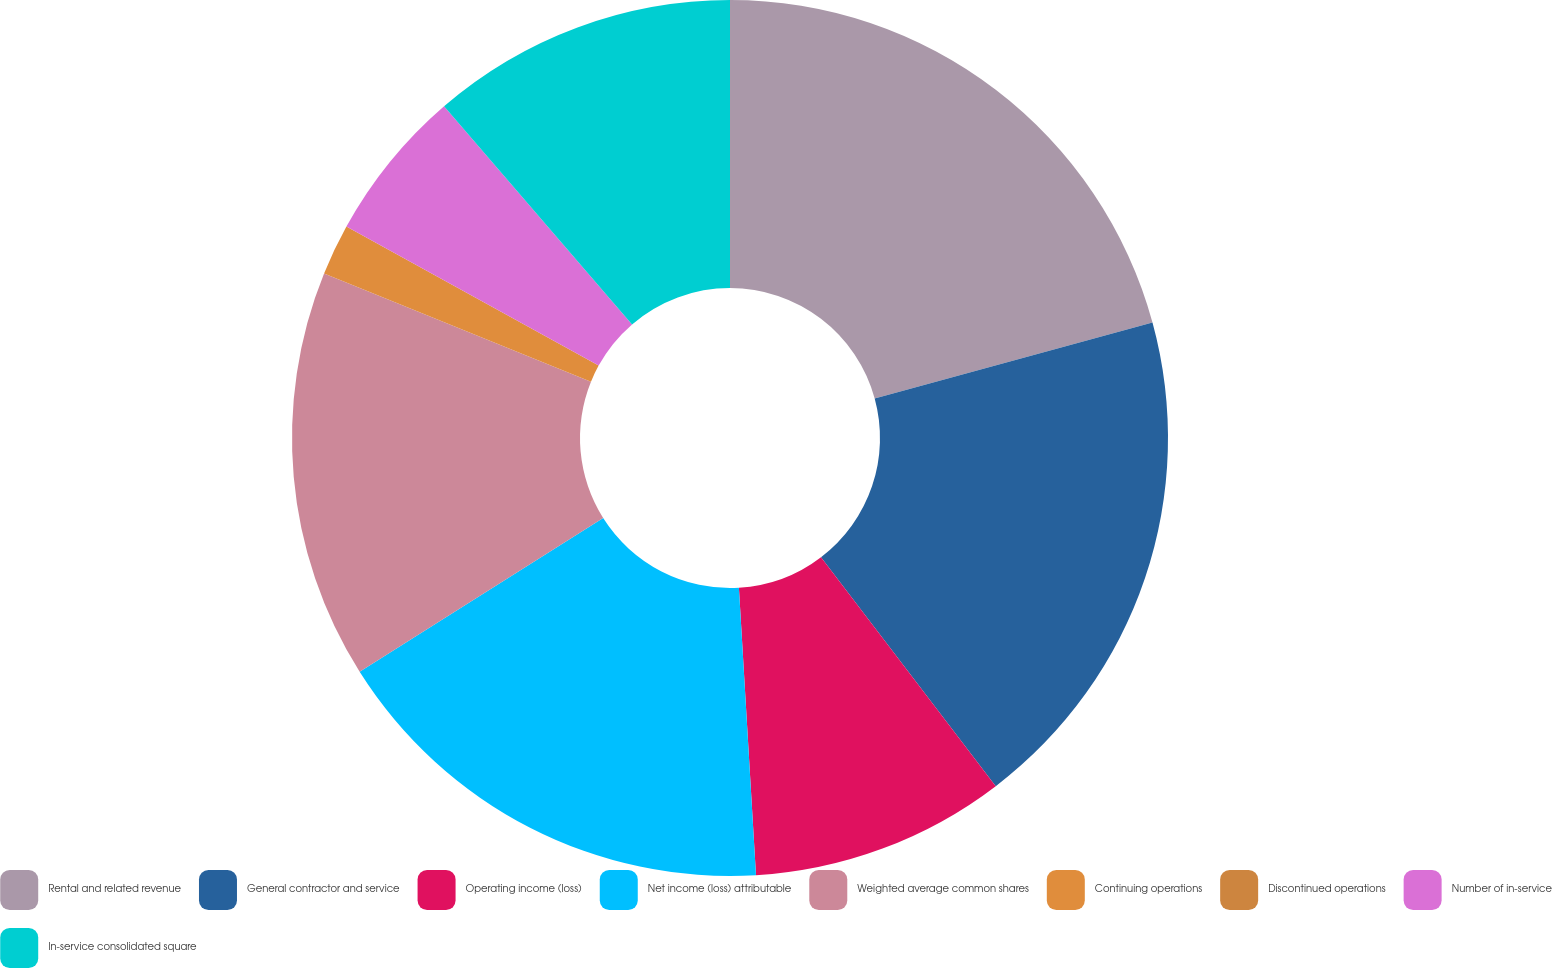Convert chart. <chart><loc_0><loc_0><loc_500><loc_500><pie_chart><fcel>Rental and related revenue<fcel>General contractor and service<fcel>Operating income (loss)<fcel>Net income (loss) attributable<fcel>Weighted average common shares<fcel>Continuing operations<fcel>Discontinued operations<fcel>Number of in-service<fcel>In-service consolidated square<nl><fcel>20.75%<fcel>18.87%<fcel>9.43%<fcel>16.98%<fcel>15.09%<fcel>1.89%<fcel>0.0%<fcel>5.66%<fcel>11.32%<nl></chart> 